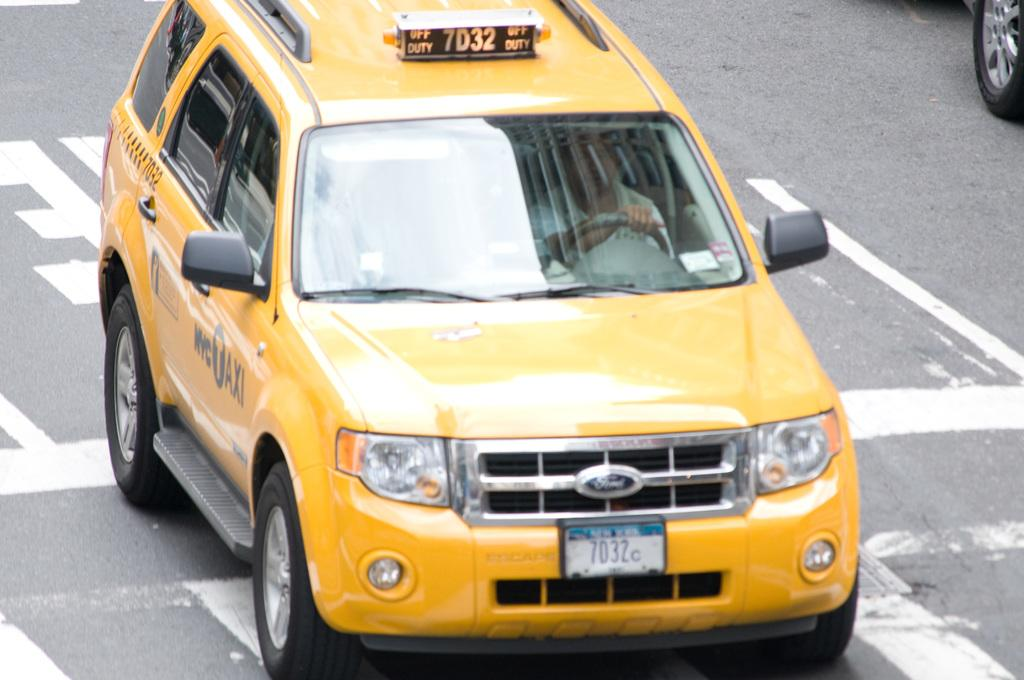<image>
Provide a brief description of the given image. A yellow taxi with the ID number of 7D32. 